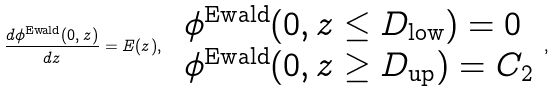<formula> <loc_0><loc_0><loc_500><loc_500>\frac { d \phi ^ { \text {Ewald} } ( 0 , z ) } { d z } = E ( z ) , \ \begin{array} { l } \phi ^ { \text {Ewald} } ( 0 , z \leq D _ { \text {low} } ) = 0 \\ \phi ^ { \text {Ewald} } ( 0 , z \geq D _ { \text {up} } ) = C _ { 2 } \end{array} \, ,</formula> 